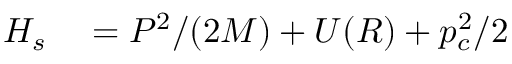<formula> <loc_0><loc_0><loc_500><loc_500>\begin{array} { r l } { H _ { s } } & = P ^ { 2 } / ( 2 M ) + U ( R ) + p _ { c } ^ { 2 } / 2 } \end{array}</formula> 